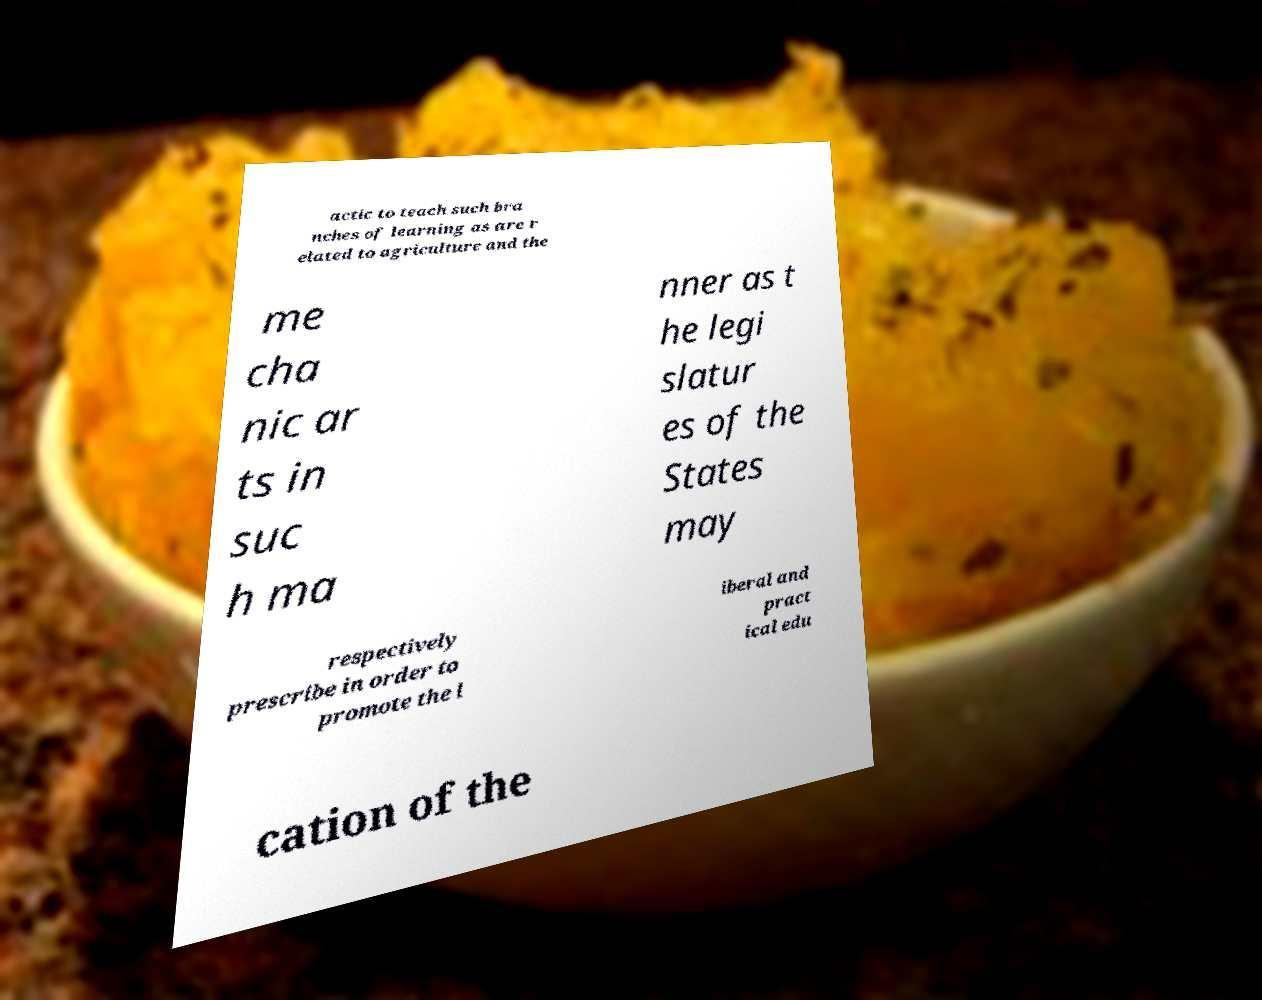Could you assist in decoding the text presented in this image and type it out clearly? actic to teach such bra nches of learning as are r elated to agriculture and the me cha nic ar ts in suc h ma nner as t he legi slatur es of the States may respectively prescribe in order to promote the l iberal and pract ical edu cation of the 